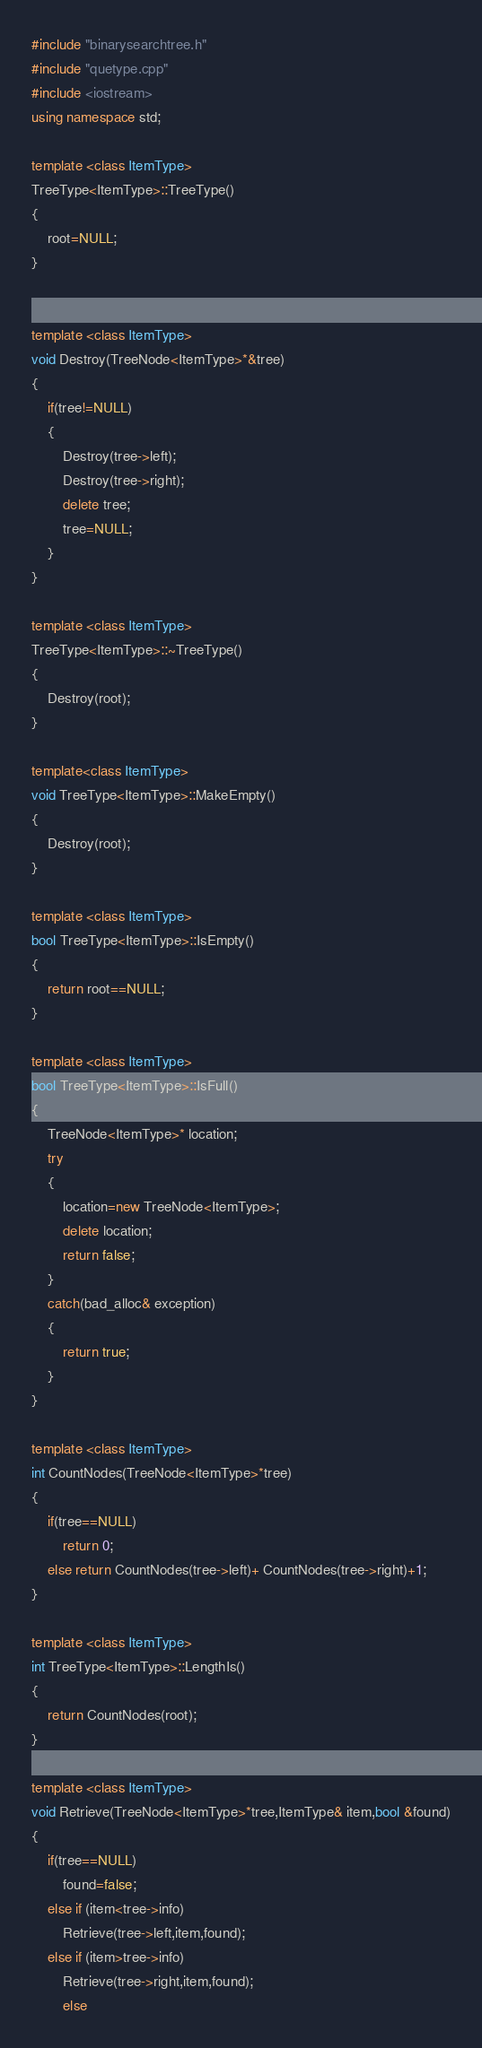Convert code to text. <code><loc_0><loc_0><loc_500><loc_500><_C++_>#include "binarysearchtree.h"
#include "quetype.cpp"
#include <iostream>
using namespace std;

template <class ItemType>
TreeType<ItemType>::TreeType()
{
    root=NULL;
}


template <class ItemType>
void Destroy(TreeNode<ItemType>*&tree)
{
    if(tree!=NULL)
    {
        Destroy(tree->left);
        Destroy(tree->right);
        delete tree;
        tree=NULL;
    }
}

template <class ItemType>
TreeType<ItemType>::~TreeType()
{
    Destroy(root);
}

template<class ItemType>
void TreeType<ItemType>::MakeEmpty()
{
    Destroy(root);
}

template <class ItemType>
bool TreeType<ItemType>::IsEmpty()
{
    return root==NULL;
}

template <class ItemType>
bool TreeType<ItemType>::IsFull()
{
    TreeNode<ItemType>* location;
    try
    {
        location=new TreeNode<ItemType>;
        delete location;
        return false;
    }
    catch(bad_alloc& exception)
    {
        return true;
    }
}

template <class ItemType>
int CountNodes(TreeNode<ItemType>*tree)
{
    if(tree==NULL)
        return 0;
    else return CountNodes(tree->left)+ CountNodes(tree->right)+1;
}

template <class ItemType>
int TreeType<ItemType>::LengthIs()
{
    return CountNodes(root);
}

template <class ItemType>
void Retrieve(TreeNode<ItemType>*tree,ItemType& item,bool &found)
{
    if(tree==NULL)
        found=false;
    else if (item<tree->info)
        Retrieve(tree->left,item,found);
    else if (item>tree->info)
        Retrieve(tree->right,item,found);
        else</code> 